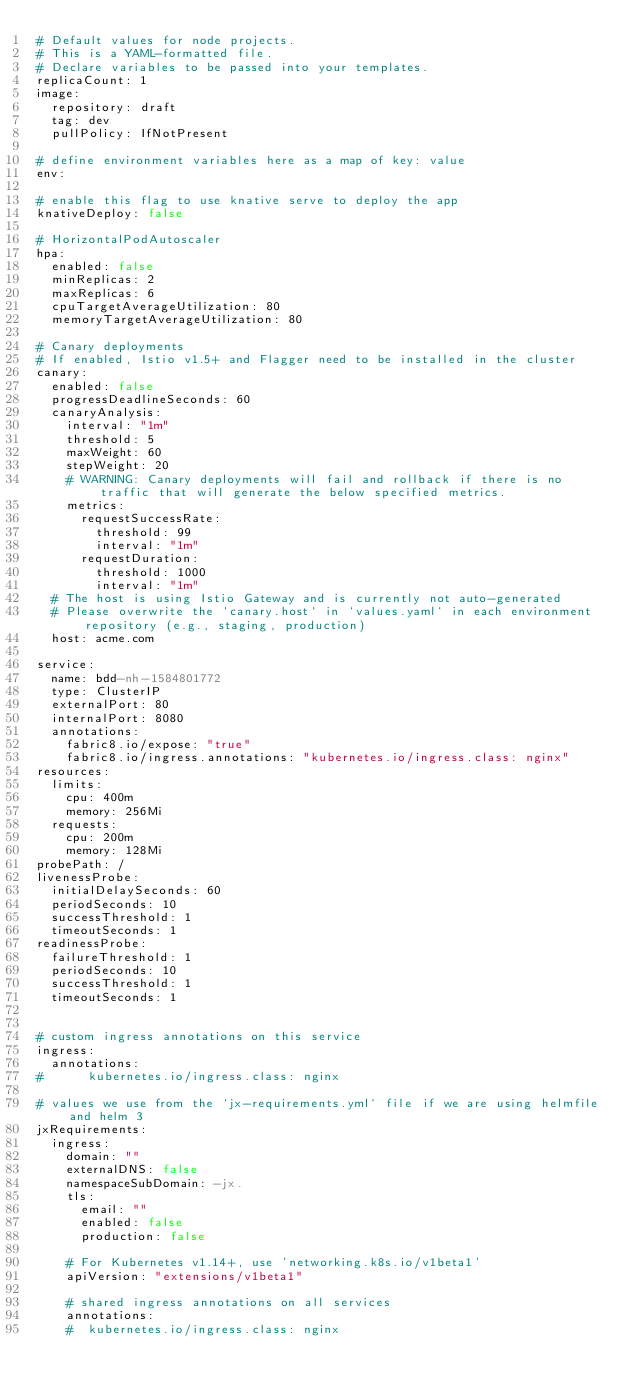Convert code to text. <code><loc_0><loc_0><loc_500><loc_500><_YAML_># Default values for node projects.
# This is a YAML-formatted file.
# Declare variables to be passed into your templates.
replicaCount: 1
image:
  repository: draft
  tag: dev
  pullPolicy: IfNotPresent

# define environment variables here as a map of key: value
env:

# enable this flag to use knative serve to deploy the app
knativeDeploy: false

# HorizontalPodAutoscaler
hpa:
  enabled: false
  minReplicas: 2
  maxReplicas: 6
  cpuTargetAverageUtilization: 80
  memoryTargetAverageUtilization: 80

# Canary deployments
# If enabled, Istio v1.5+ and Flagger need to be installed in the cluster
canary:
  enabled: false
  progressDeadlineSeconds: 60
  canaryAnalysis:
    interval: "1m"
    threshold: 5
    maxWeight: 60
    stepWeight: 20
    # WARNING: Canary deployments will fail and rollback if there is no traffic that will generate the below specified metrics.
    metrics:
      requestSuccessRate:
        threshold: 99
        interval: "1m"
      requestDuration:
        threshold: 1000
        interval: "1m"
  # The host is using Istio Gateway and is currently not auto-generated
  # Please overwrite the `canary.host` in `values.yaml` in each environment repository (e.g., staging, production)
  host: acme.com

service:
  name: bdd-nh-1584801772
  type: ClusterIP
  externalPort: 80
  internalPort: 8080
  annotations:
    fabric8.io/expose: "true"
    fabric8.io/ingress.annotations: "kubernetes.io/ingress.class: nginx"
resources:
  limits:
    cpu: 400m
    memory: 256Mi
  requests:
    cpu: 200m
    memory: 128Mi
probePath: /
livenessProbe:
  initialDelaySeconds: 60
  periodSeconds: 10
  successThreshold: 1
  timeoutSeconds: 1
readinessProbe:
  failureThreshold: 1
  periodSeconds: 10
  successThreshold: 1
  timeoutSeconds: 1


# custom ingress annotations on this service
ingress:
  annotations:
#      kubernetes.io/ingress.class: nginx

# values we use from the `jx-requirements.yml` file if we are using helmfile and helm 3
jxRequirements:
  ingress:
    domain: ""
    externalDNS: false
    namespaceSubDomain: -jx.
    tls:
      email: ""
      enabled: false
      production: false

    # For Kubernetes v1.14+, use 'networking.k8s.io/v1beta1'
    apiVersion: "extensions/v1beta1"

    # shared ingress annotations on all services
    annotations:
    #  kubernetes.io/ingress.class: nginx
</code> 